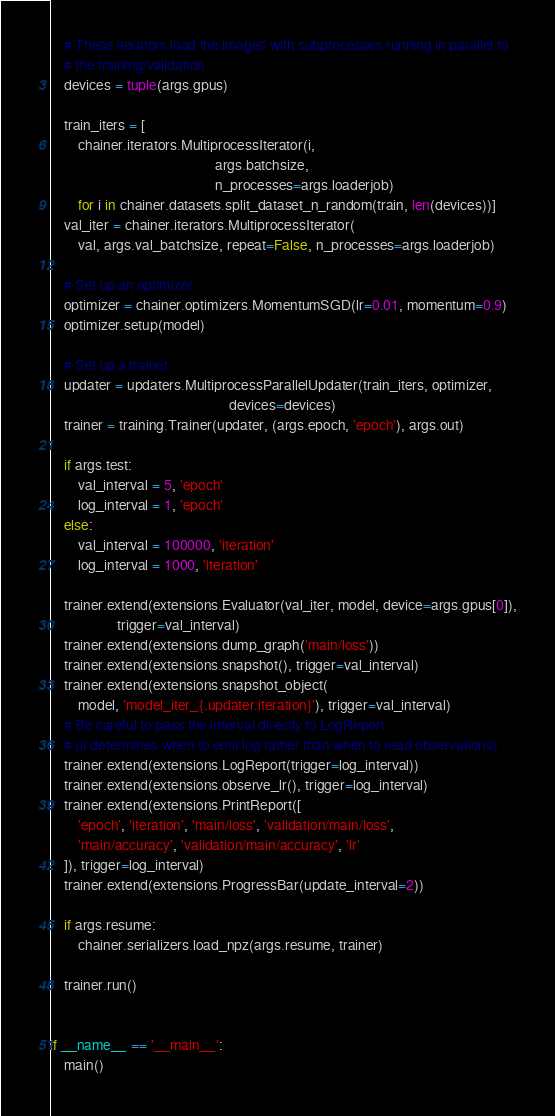<code> <loc_0><loc_0><loc_500><loc_500><_Python_>    # These iterators load the images with subprocesses running in parallel to
    # the training/validation.
    devices = tuple(args.gpus)

    train_iters = [
        chainer.iterators.MultiprocessIterator(i,
                                               args.batchsize,
                                               n_processes=args.loaderjob)
        for i in chainer.datasets.split_dataset_n_random(train, len(devices))]
    val_iter = chainer.iterators.MultiprocessIterator(
        val, args.val_batchsize, repeat=False, n_processes=args.loaderjob)

    # Set up an optimizer
    optimizer = chainer.optimizers.MomentumSGD(lr=0.01, momentum=0.9)
    optimizer.setup(model)

    # Set up a trainer
    updater = updaters.MultiprocessParallelUpdater(train_iters, optimizer,
                                                   devices=devices)
    trainer = training.Trainer(updater, (args.epoch, 'epoch'), args.out)

    if args.test:
        val_interval = 5, 'epoch'
        log_interval = 1, 'epoch'
    else:
        val_interval = 100000, 'iteration'
        log_interval = 1000, 'iteration'

    trainer.extend(extensions.Evaluator(val_iter, model, device=args.gpus[0]),
                   trigger=val_interval)
    trainer.extend(extensions.dump_graph('main/loss'))
    trainer.extend(extensions.snapshot(), trigger=val_interval)
    trainer.extend(extensions.snapshot_object(
        model, 'model_iter_{.updater.iteration}'), trigger=val_interval)
    # Be careful to pass the interval directly to LogReport
    # (it determines when to emit log rather than when to read observations)
    trainer.extend(extensions.LogReport(trigger=log_interval))
    trainer.extend(extensions.observe_lr(), trigger=log_interval)
    trainer.extend(extensions.PrintReport([
        'epoch', 'iteration', 'main/loss', 'validation/main/loss',
        'main/accuracy', 'validation/main/accuracy', 'lr'
    ]), trigger=log_interval)
    trainer.extend(extensions.ProgressBar(update_interval=2))

    if args.resume:
        chainer.serializers.load_npz(args.resume, trainer)

    trainer.run()


if __name__ == '__main__':
    main()
</code> 